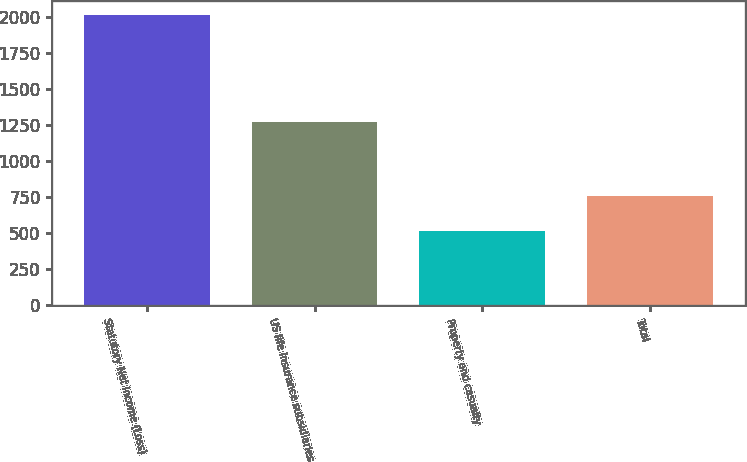Convert chart to OTSL. <chart><loc_0><loc_0><loc_500><loc_500><bar_chart><fcel>Statutory Net Income (Loss)<fcel>US life insurance subsidiaries<fcel>Property and casualty<fcel>Total<nl><fcel>2011<fcel>1272<fcel>514<fcel>758<nl></chart> 